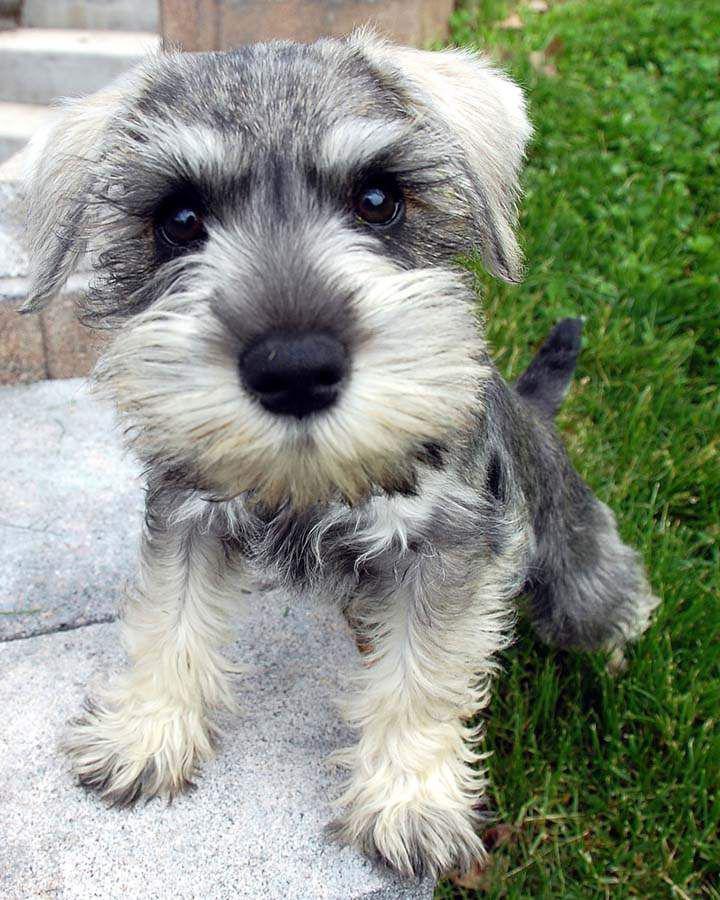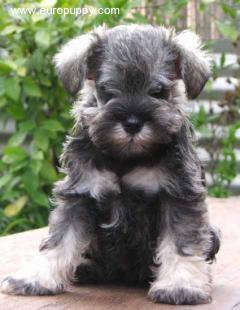The first image is the image on the left, the second image is the image on the right. Examine the images to the left and right. Is the description "An image shows one forward facing dog wearing a red collar." accurate? Answer yes or no. No. 